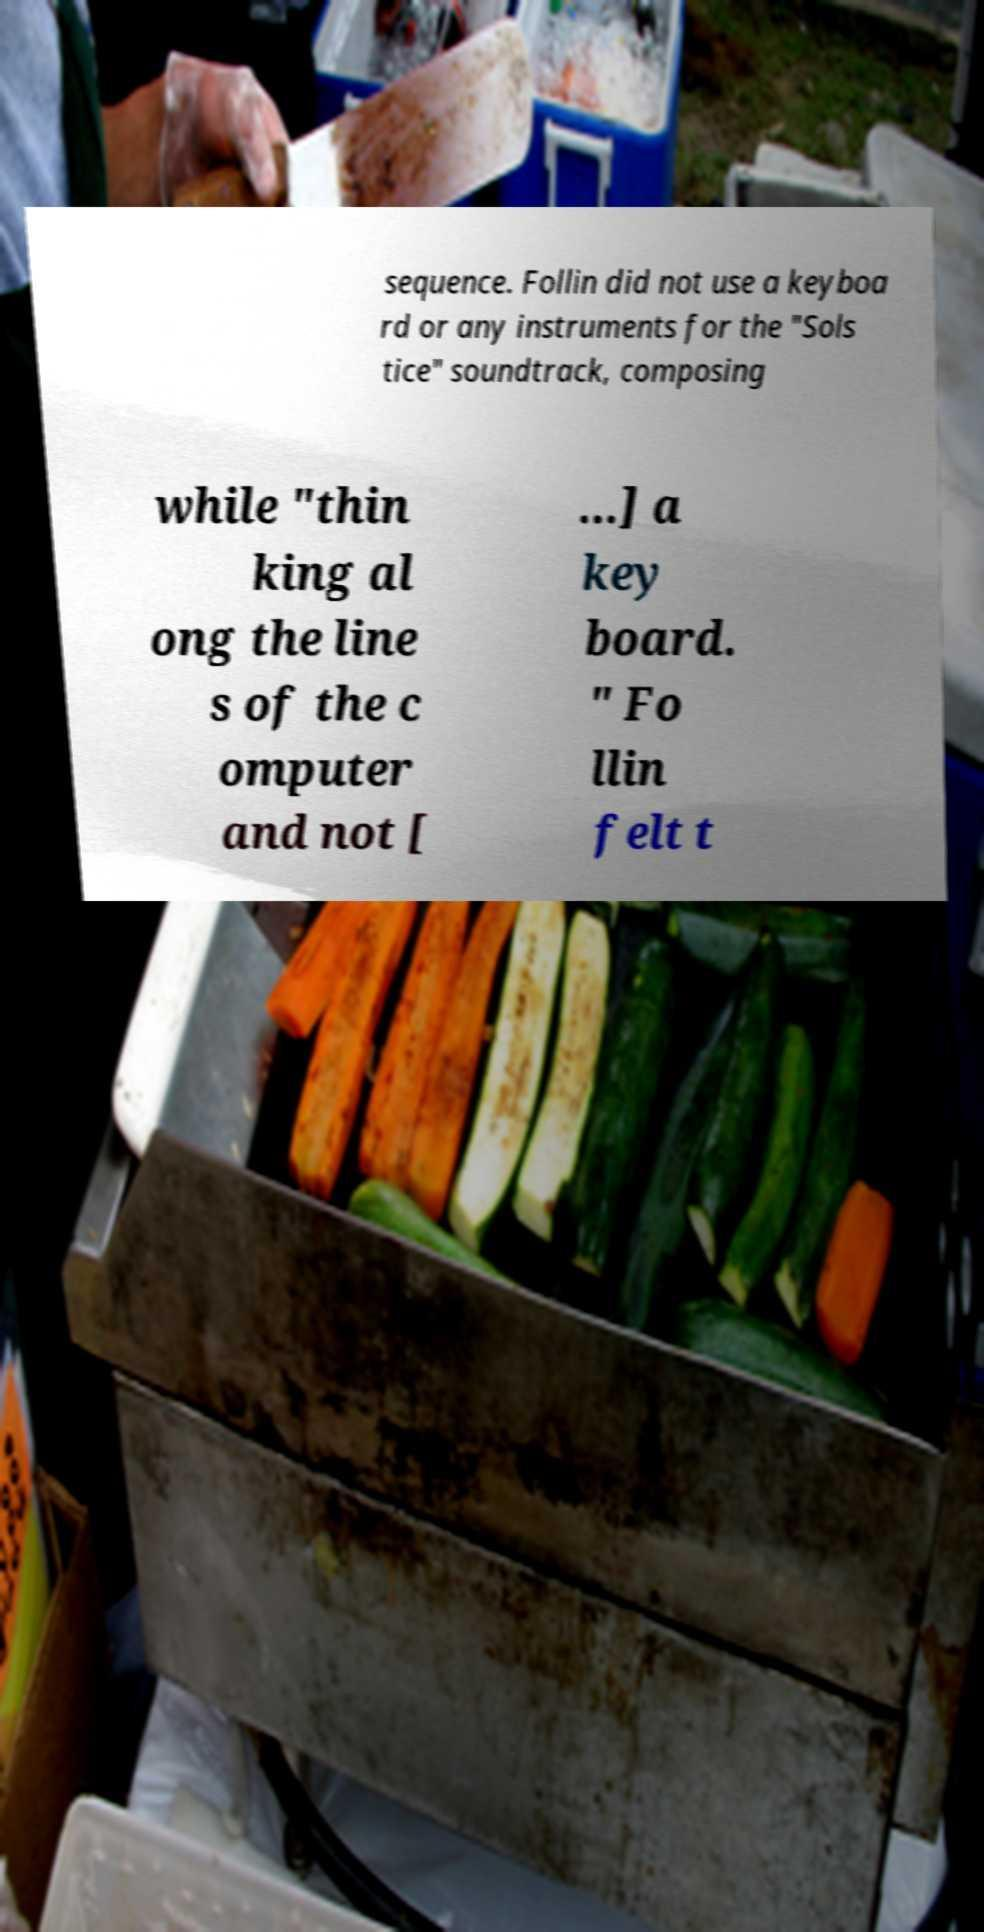Please identify and transcribe the text found in this image. sequence. Follin did not use a keyboa rd or any instruments for the "Sols tice" soundtrack, composing while "thin king al ong the line s of the c omputer and not [ ...] a key board. " Fo llin felt t 